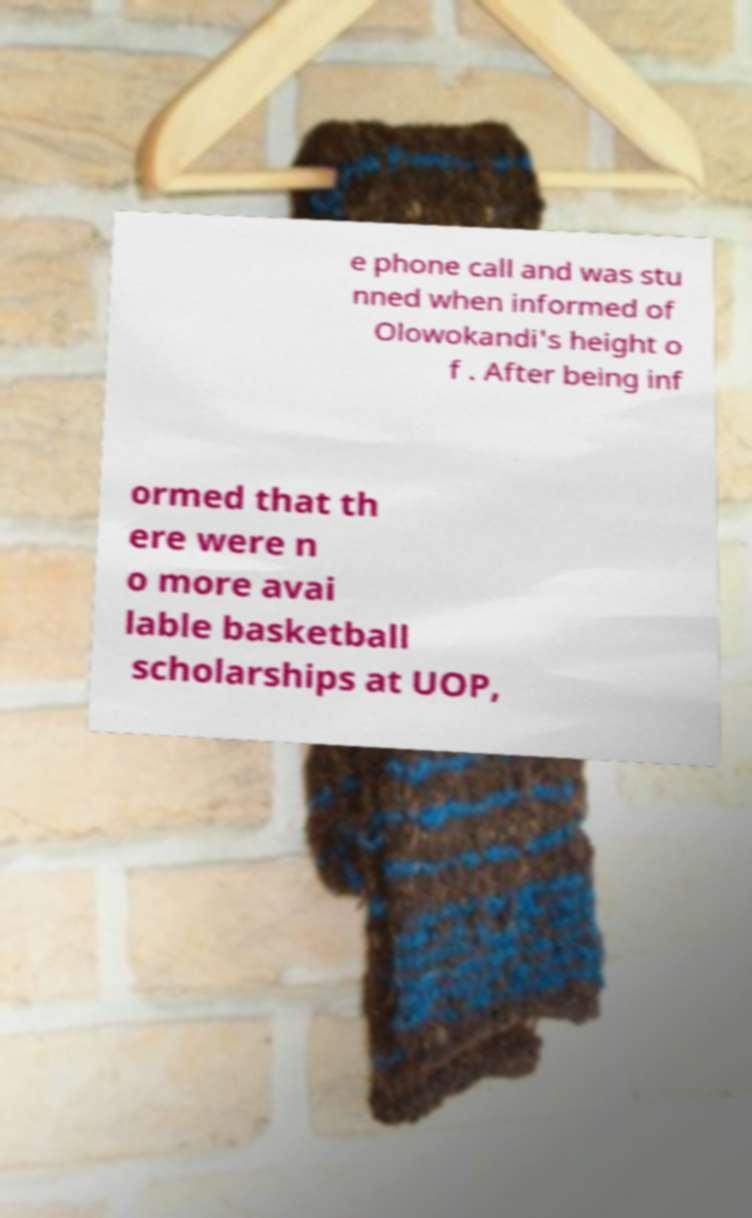There's text embedded in this image that I need extracted. Can you transcribe it verbatim? e phone call and was stu nned when informed of Olowokandi's height o f . After being inf ormed that th ere were n o more avai lable basketball scholarships at UOP, 